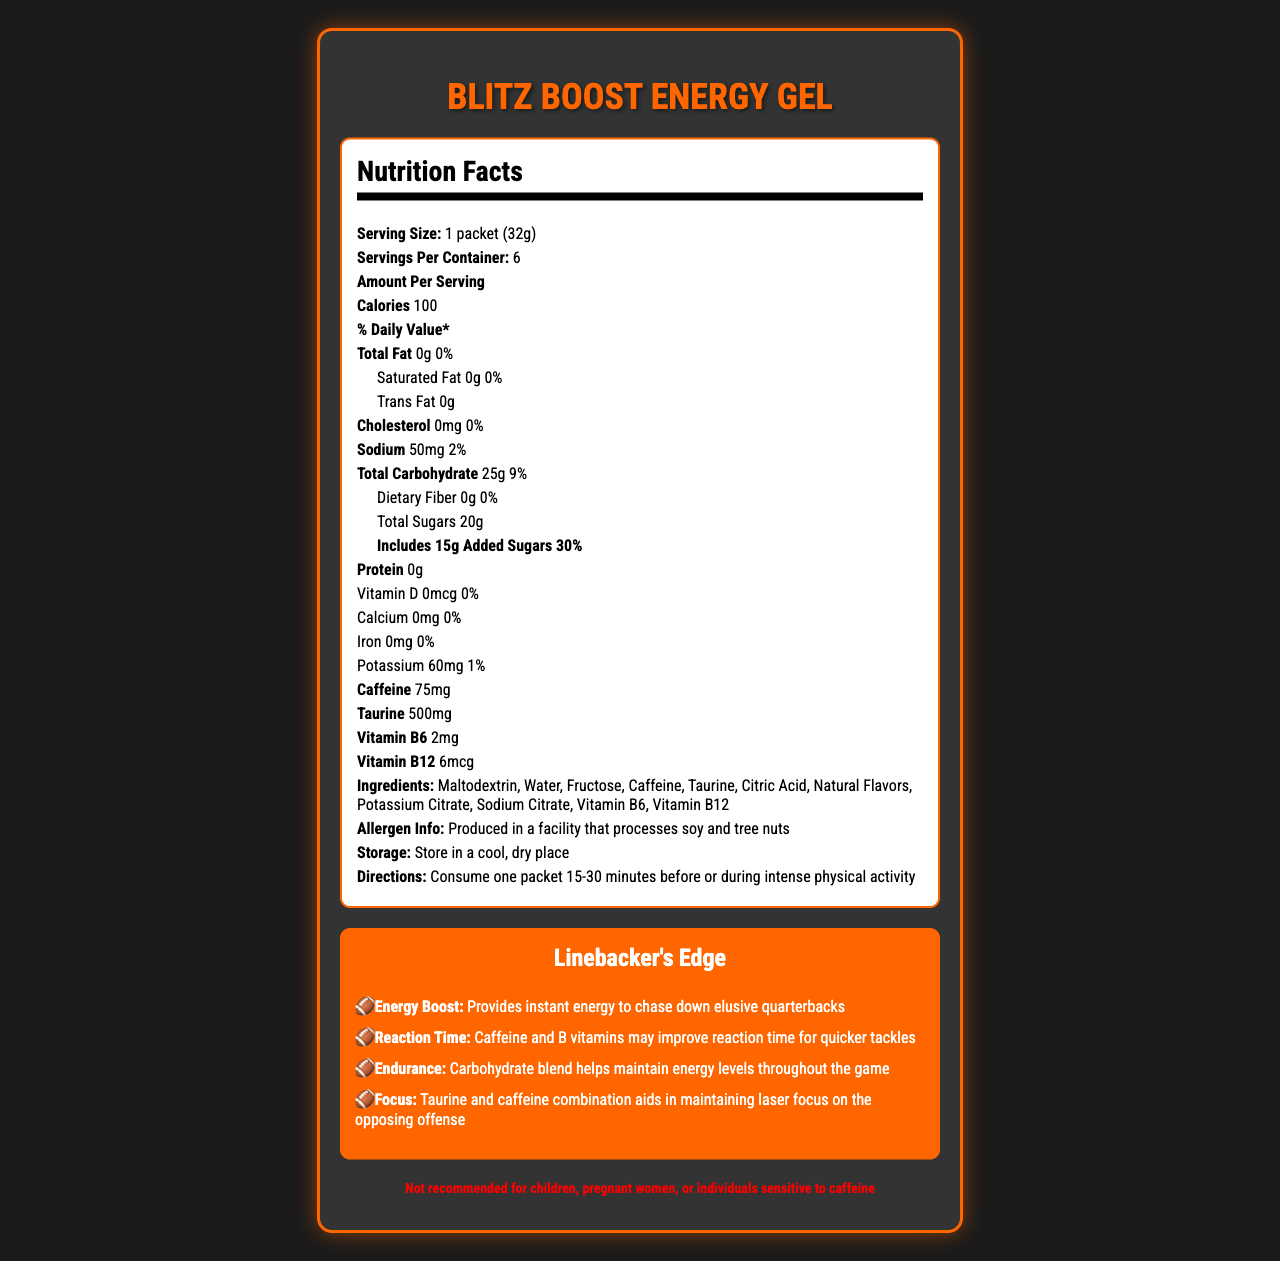what is the total carbohydrate content per serving? The nutrition facts label specifies that the total carbohydrate content per serving is 25g.
Answer: 25g how much caffeine does one packet of Blitz Boost Energy Gel contain? The nutrition facts label states that one packet contains 75mg of caffeine.
Answer: 75mg how many calories are in one serving of Blitz Boost Energy Gel? According to the nutrition facts label, one serving contains 100 calories.
Answer: 100 calories which ingredients are found in Blitz Boost Energy Gel? The ingredients are listed on the nutrition facts label.
Answer: Maltodextrin, Water, Fructose, Caffeine, Taurine, Citric Acid, Natural Flavors, Potassium Citrate, Sodium Citrate, Vitamin B6, Vitamin B12 what is the primary benefit of taurine in this energy gel? The linebacker's edge section states that taurine and caffeine help maintain laser focus.
Answer: Aids in maintaining laser focus on the opposing offense is this product recommended for children or pregnant women? The warning states it's not recommended for children, pregnant women, or individuals sensitive to caffeine.
Answer: No which element in the nutrition facts label is purely for texture? Citric Acid is typically used for flavor and preservation, not for nutritional value.
Answer: Citric Acid how should Blitz Boost Energy Gel be stored? The storage instructions say to store it in a cool, dry place.
Answer: In a cool, dry place when should one consume Blitz Boost Energy Gel for best results? A. 5-10 minutes before activity B. 15-30 minutes before or during activity C. Only after activity D. During meals The directions advise consuming one packet 15-30 minutes before or during intense physical activity.
Answer: B which of the following best explains the function of B vitamins in the Blitz Boost Energy Gel? A. Aid muscle recovery B. Improve sleep quality C. Enhance focus and alertness B vitamins, along with caffeine, contribute to enhancing focus and alertness as stated in the product claims.
Answer: C who should avoid consuming this product? A. Adults B. Team coaches C. Children and pregnant women D. Professional athletes The warning specifies that children, pregnant women, and individuals sensitive to caffeine should avoid the product.
Answer: C does Blitz Boost Energy Gel contain any protein? The nutrition facts label lists 0g of protein per serving.
Answer: No summarize the main benefits of Blitz Boost Energy Gel for a linebacker. The linebacker's edge section outlines that the energy gel provides these specific benefits.
Answer: Instant burst of energy, improved reaction time, sustained endurance, and maintained focus on the field what is the source of energy in Blitz Boost Energy Gel? The specific source (carbs, sugars, etc.) providing the burst of energy is not explicitly detailed in any single part of the document.
Answer: Cannot be determined 